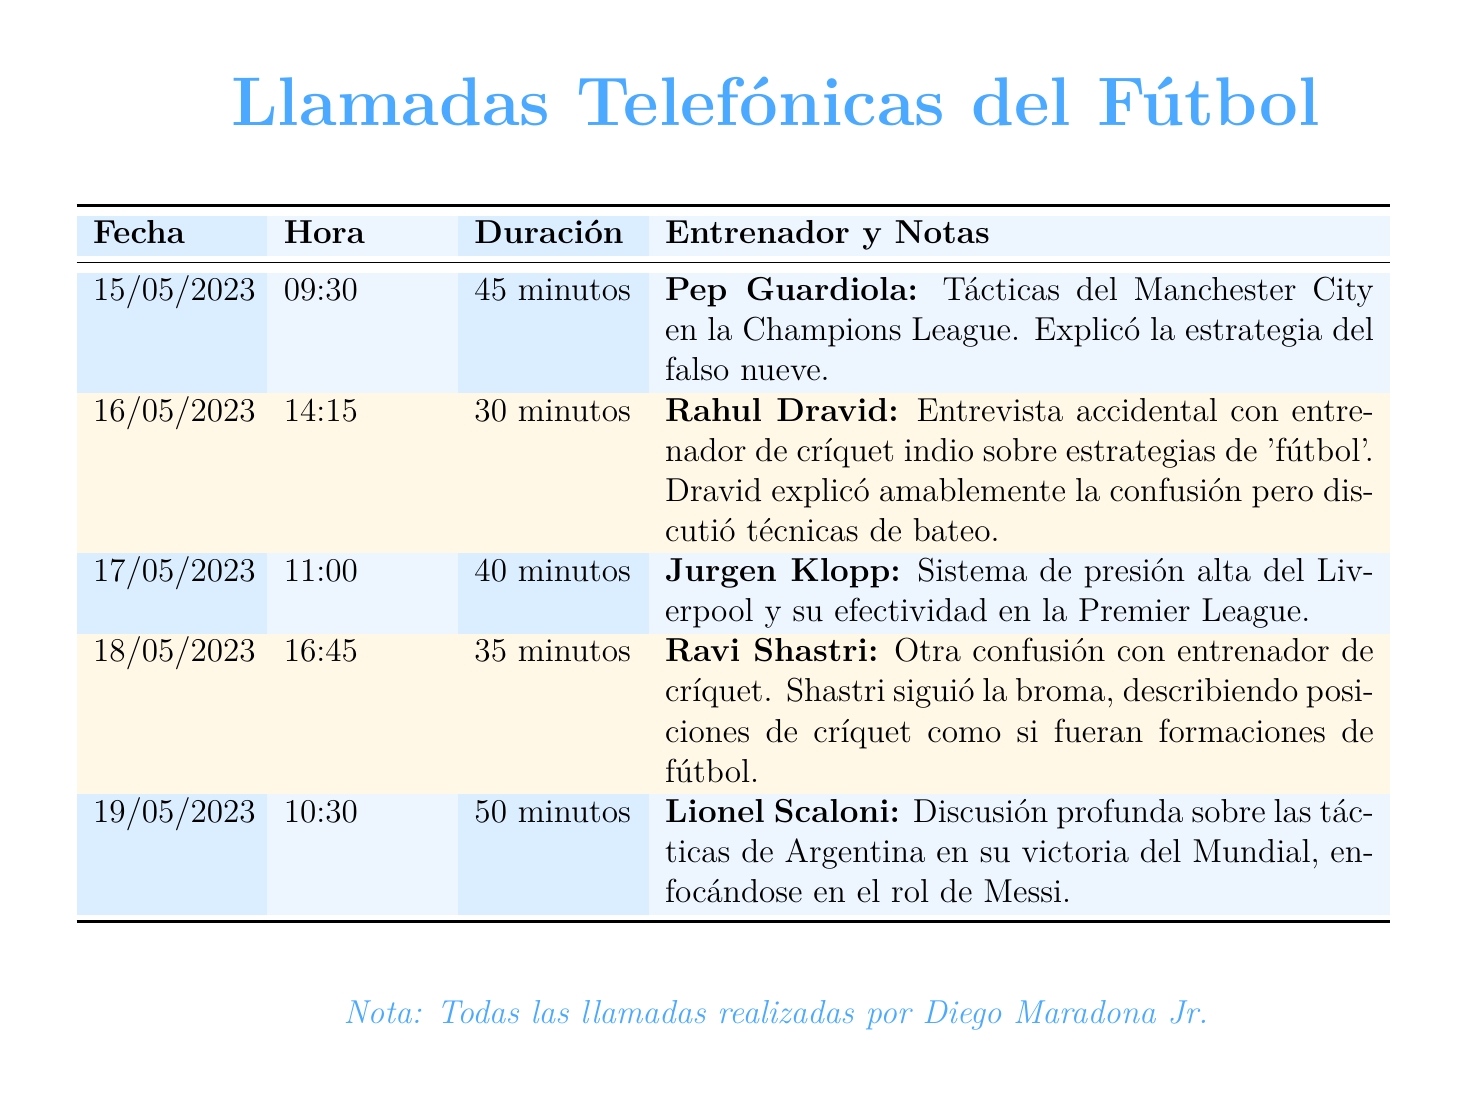what is the date of the call with Pep Guardiola? The call with Pep Guardiola took place on May 15, 2023.
Answer: 15/05/2023 who was mistakenly interviewed about cricket? The mistakenly interviewed person about cricket was Rahul Dravid.
Answer: Rahul Dravid what was the duration of the call with Lionel Scaloni? The duration of the call with Lionel Scaloni was 50 minutes.
Answer: 50 minutos what was the main topic discussed with Jurgen Klopp? The main topic discussed with Jurgen Klopp was the system of pressure high of Liverpool.
Answer: Sistema de presión alta how many calls were made to cricket coaches? There were two calls made to cricket coaches.
Answer: Dos what tactical aspect did Pep Guardiola explain? Pep Guardiola explained the strategy of the false nine.
Answer: Estrategia del falso nueve which manager discussed Argentina's tactics in the World Cup? The manager who discussed Argentina's tactics in the World Cup was Lionel Scaloni.
Answer: Lionel Scaloni what was noted in the document regarding all calls made? All the calls were noted as having been made by Diego Maradona Jr.
Answer: Diego Maradona Jr 